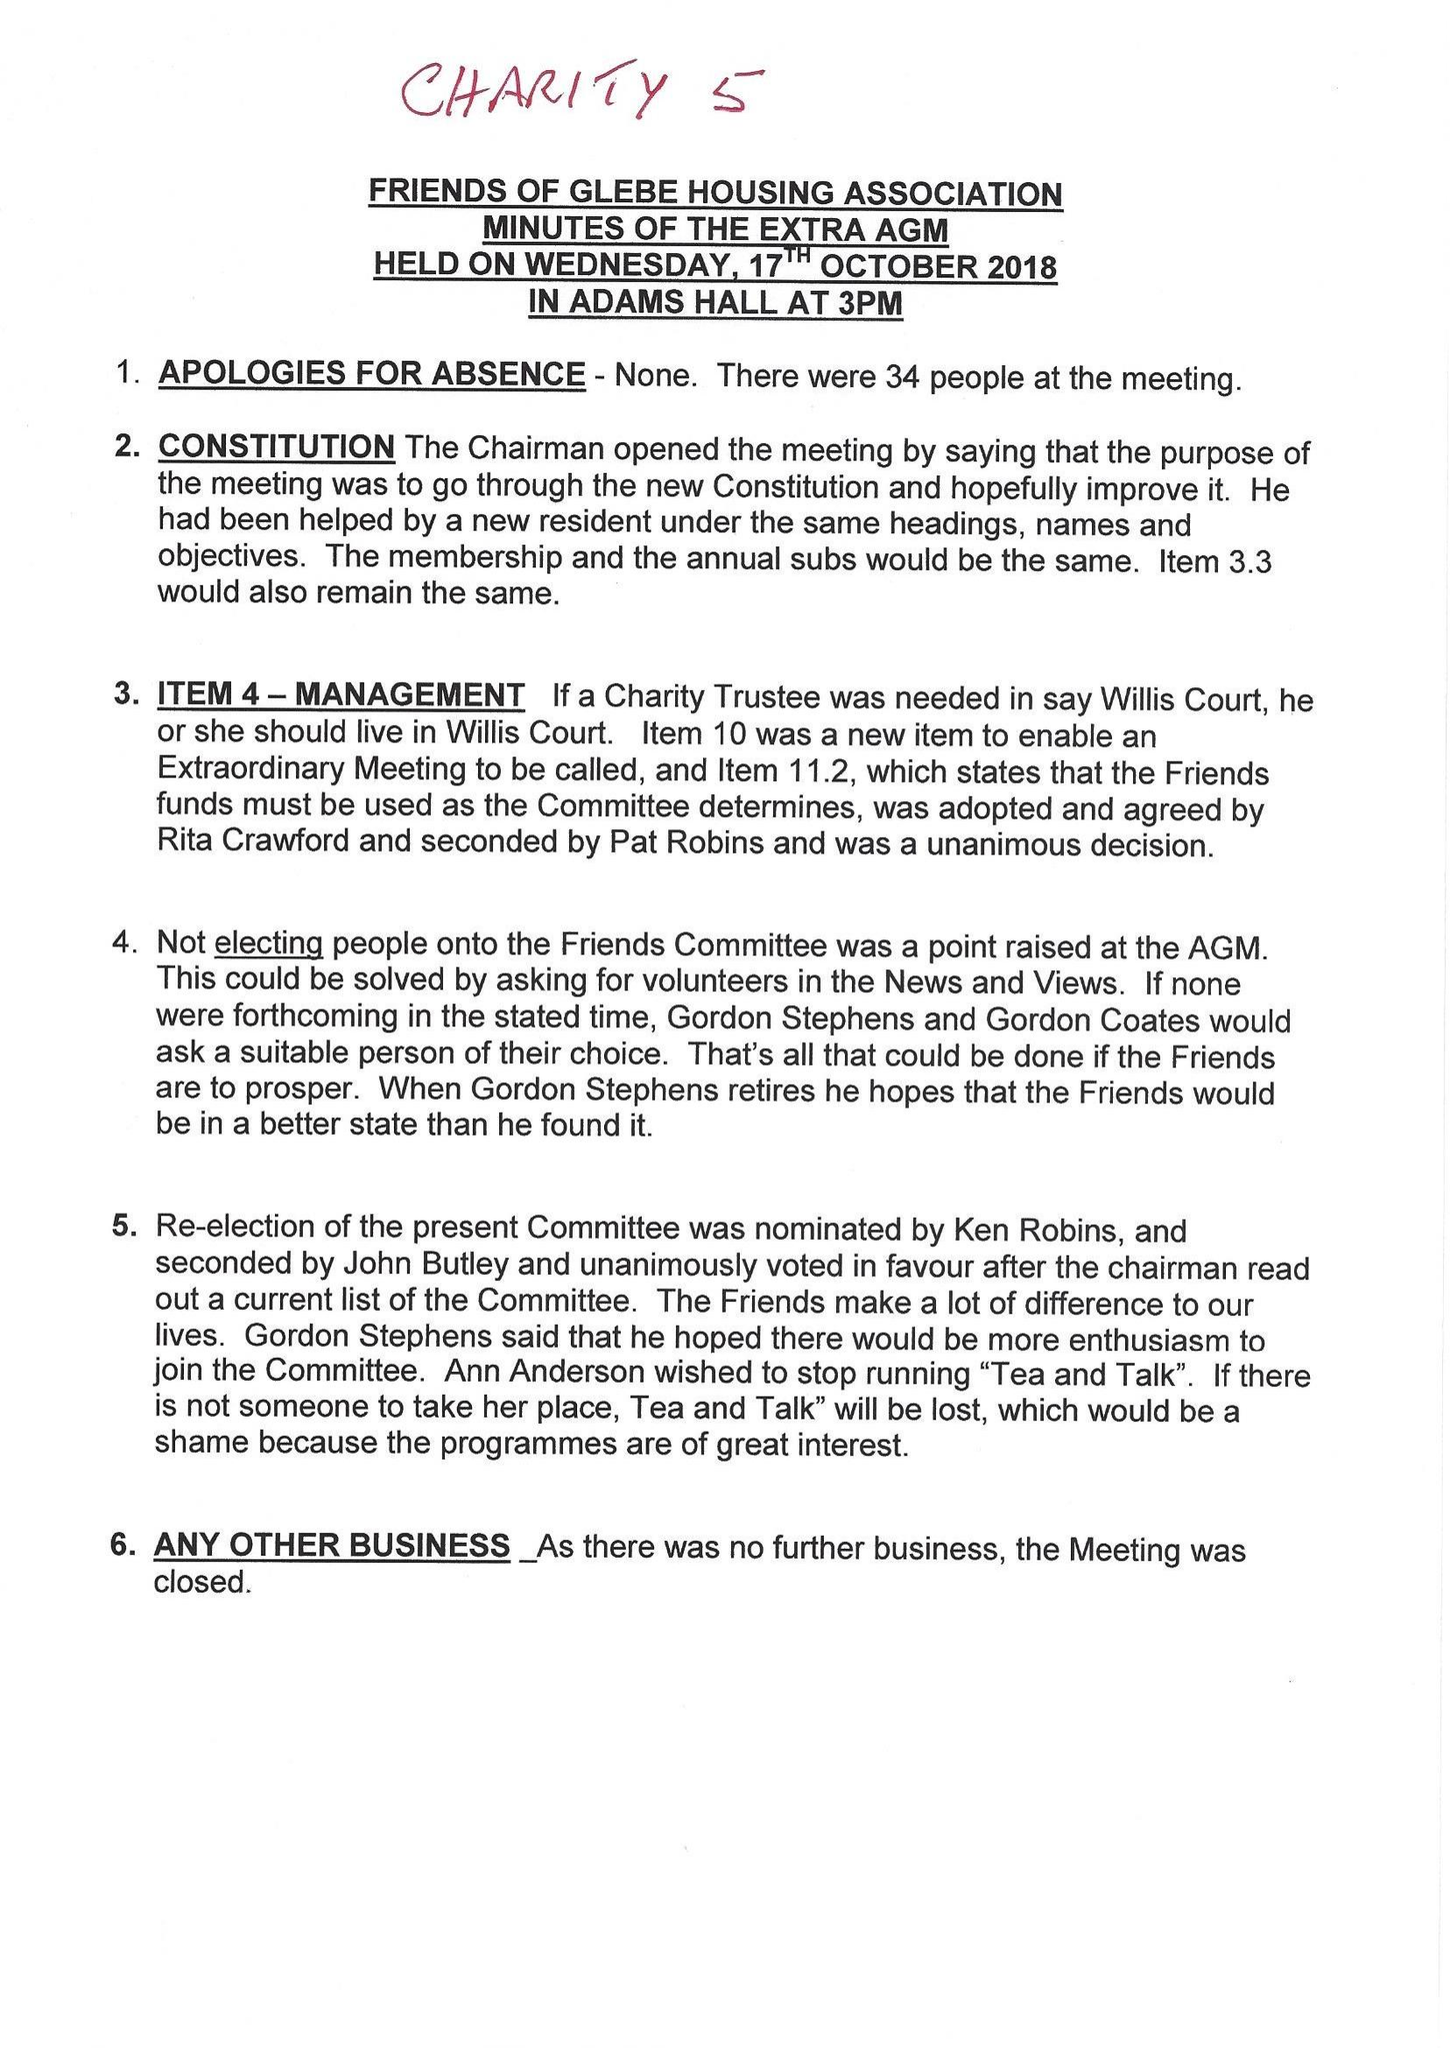What is the value for the report_date?
Answer the question using a single word or phrase. 2018-03-31 